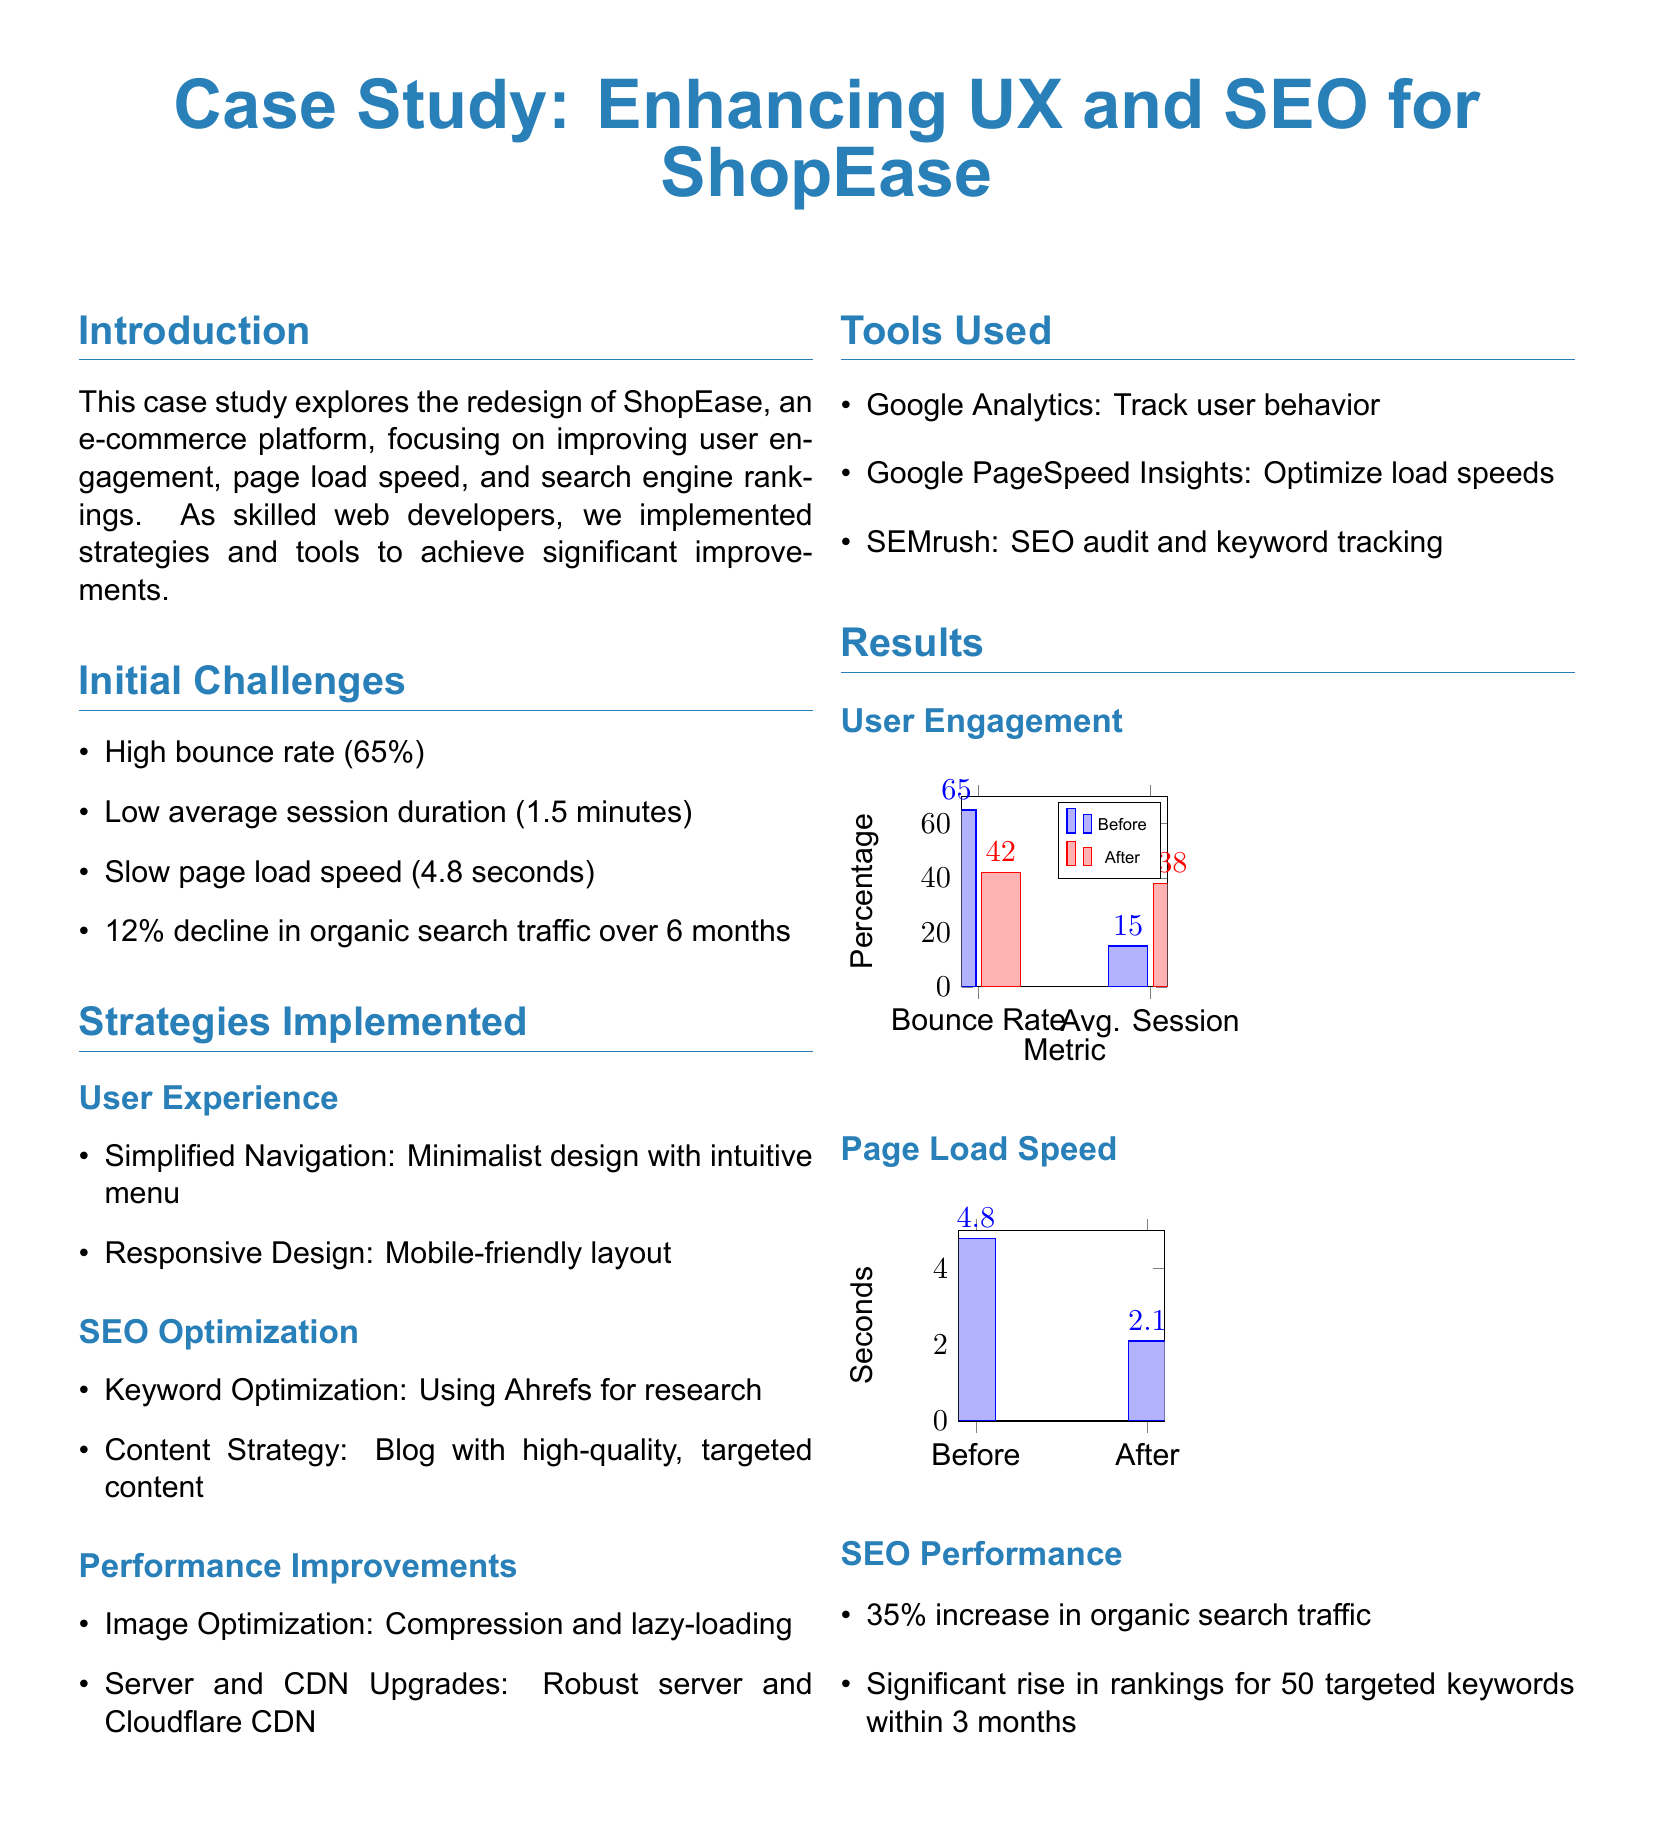What was the high bounce rate? The document states that the high bounce rate was 65%.
Answer: 65% What was the average session duration before redesign? The average session duration before the redesign was 1.5 minutes.
Answer: 1.5 minutes What was the page load speed improvement after the redesign? The page load speed improved from 4.8 seconds to 2.1 seconds.
Answer: 2.1 seconds What tool was used for keyword tracking? SEMrush was used for SEO audit and keyword tracking.
Answer: SEMrush What percentage increase in organic search traffic was achieved? There was a 35% increase in organic search traffic after the redesign.
Answer: 35% Which strategy involved a minimalist design? The strategy that involved a minimalist design was Simplified Navigation.
Answer: Simplified Navigation What was the percentage of bounce rate after redesign? The bounce rate decreased to 42% after the redesign.
Answer: 42% How many targeted keywords saw a rise in rankings? Significant rise in rankings occurred for 50 targeted keywords.
Answer: 50 What kind of server upgrade was implemented? A robust server upgrade was implemented.
Answer: Robust server 